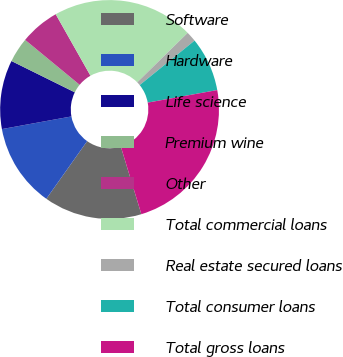Convert chart. <chart><loc_0><loc_0><loc_500><loc_500><pie_chart><fcel>Software<fcel>Hardware<fcel>Life science<fcel>Premium wine<fcel>Other<fcel>Total commercial loans<fcel>Real estate secured loans<fcel>Total consumer loans<fcel>Total gross loans<nl><fcel>14.5%<fcel>12.33%<fcel>10.17%<fcel>3.67%<fcel>5.84%<fcel>20.84%<fcel>1.51%<fcel>8.0%<fcel>23.15%<nl></chart> 